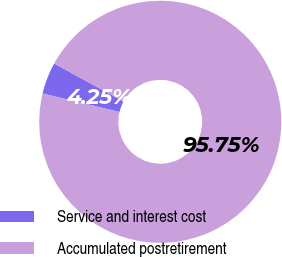Convert chart. <chart><loc_0><loc_0><loc_500><loc_500><pie_chart><fcel>Service and interest cost<fcel>Accumulated postretirement<nl><fcel>4.25%<fcel>95.75%<nl></chart> 